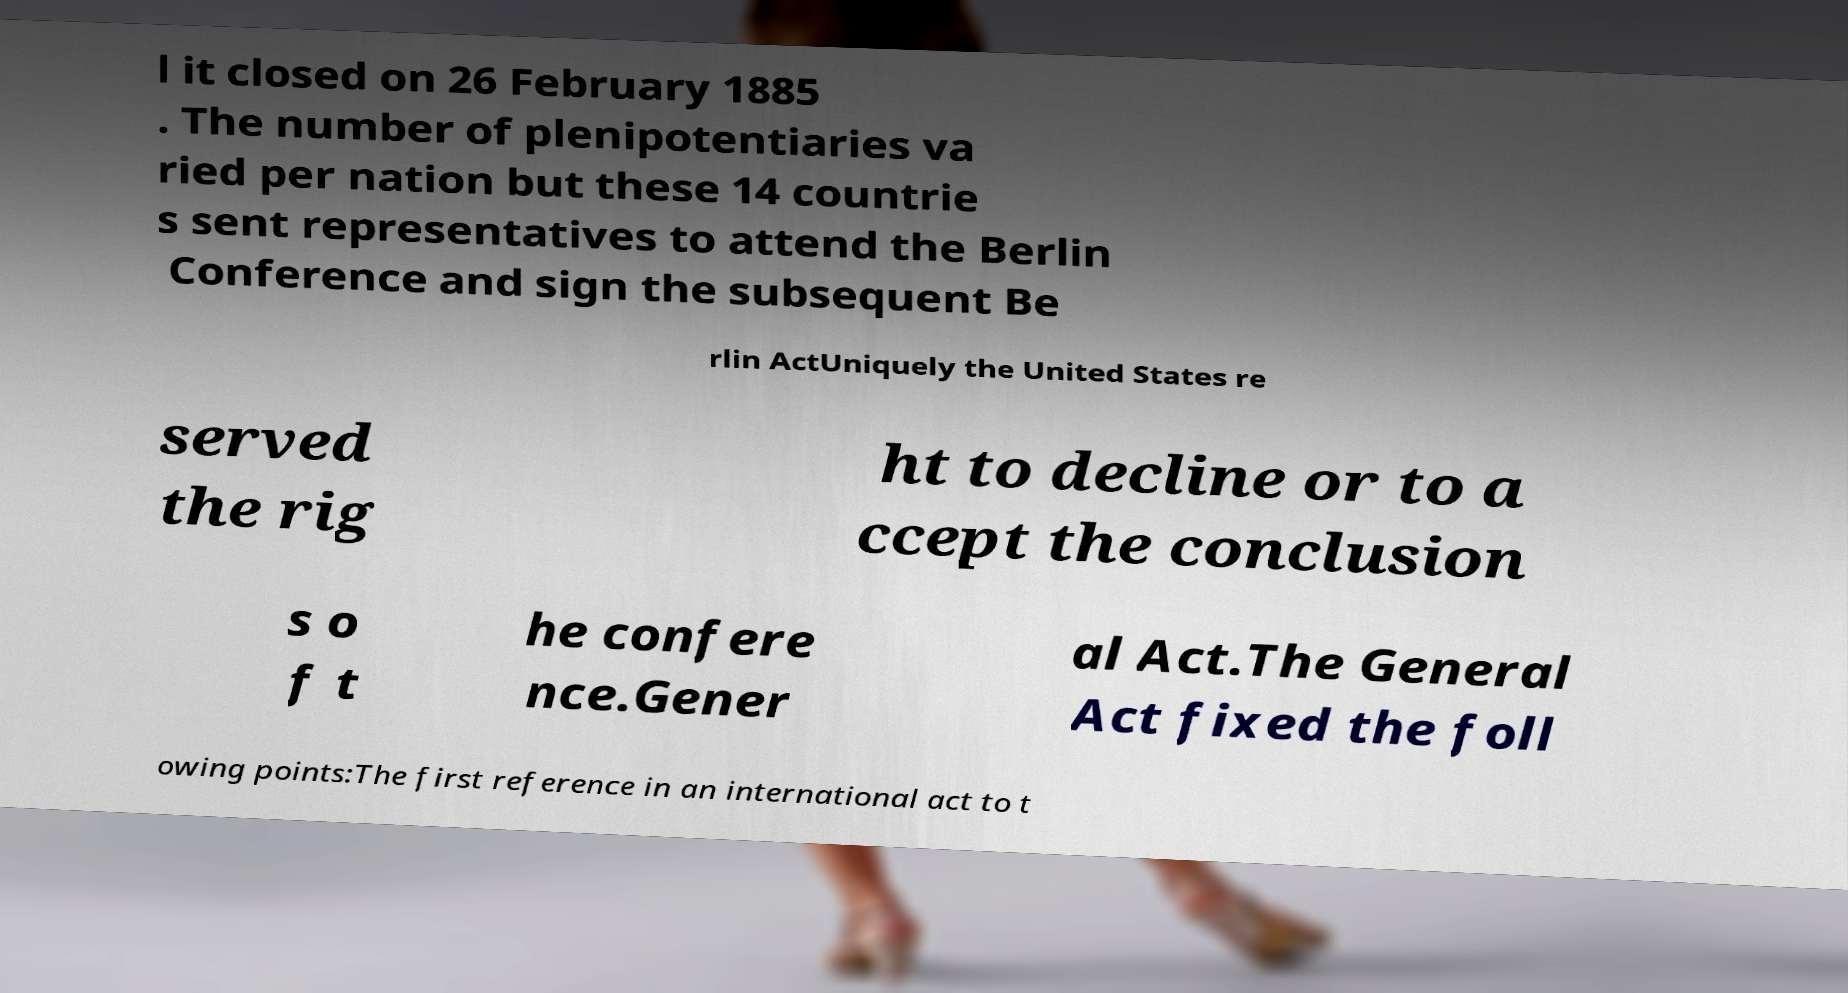Could you extract and type out the text from this image? l it closed on 26 February 1885 . The number of plenipotentiaries va ried per nation but these 14 countrie s sent representatives to attend the Berlin Conference and sign the subsequent Be rlin ActUniquely the United States re served the rig ht to decline or to a ccept the conclusion s o f t he confere nce.Gener al Act.The General Act fixed the foll owing points:The first reference in an international act to t 